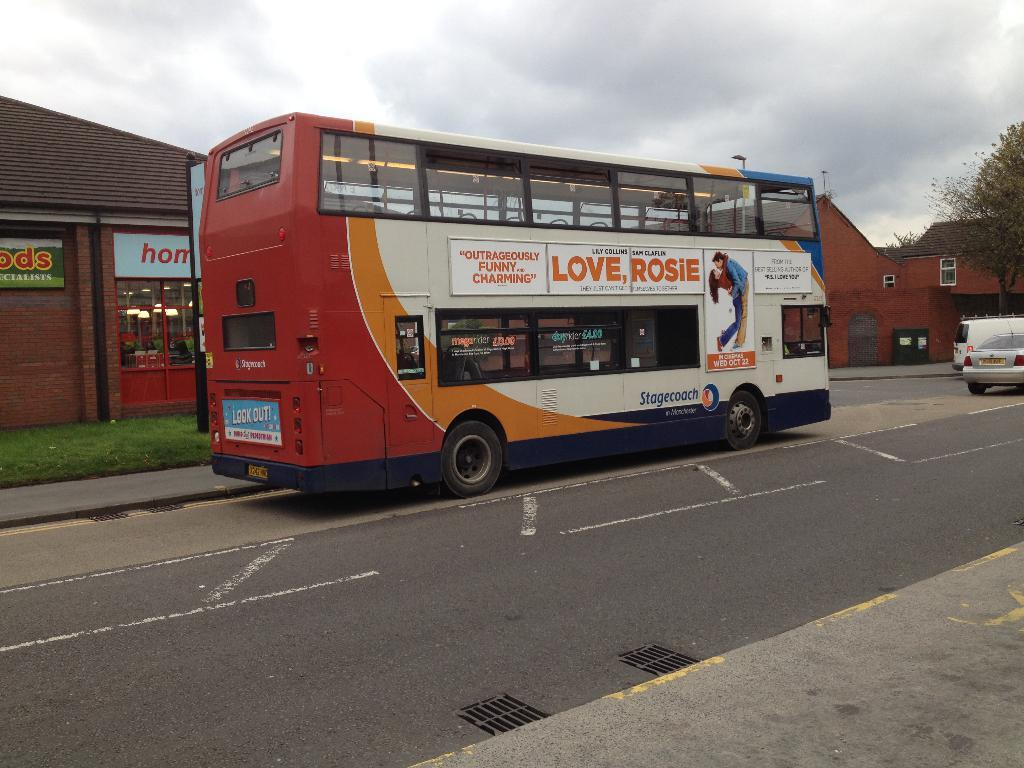Provide a one-sentence caption for the provided image. A double decker bus on a road with an advertisement for Love Rosie on the side. 